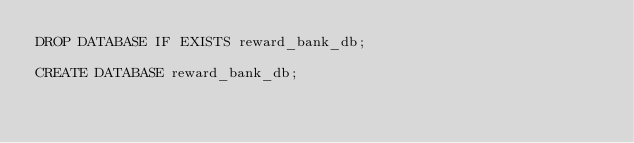Convert code to text. <code><loc_0><loc_0><loc_500><loc_500><_SQL_>DROP DATABASE IF EXISTS reward_bank_db;

CREATE DATABASE reward_bank_db;</code> 